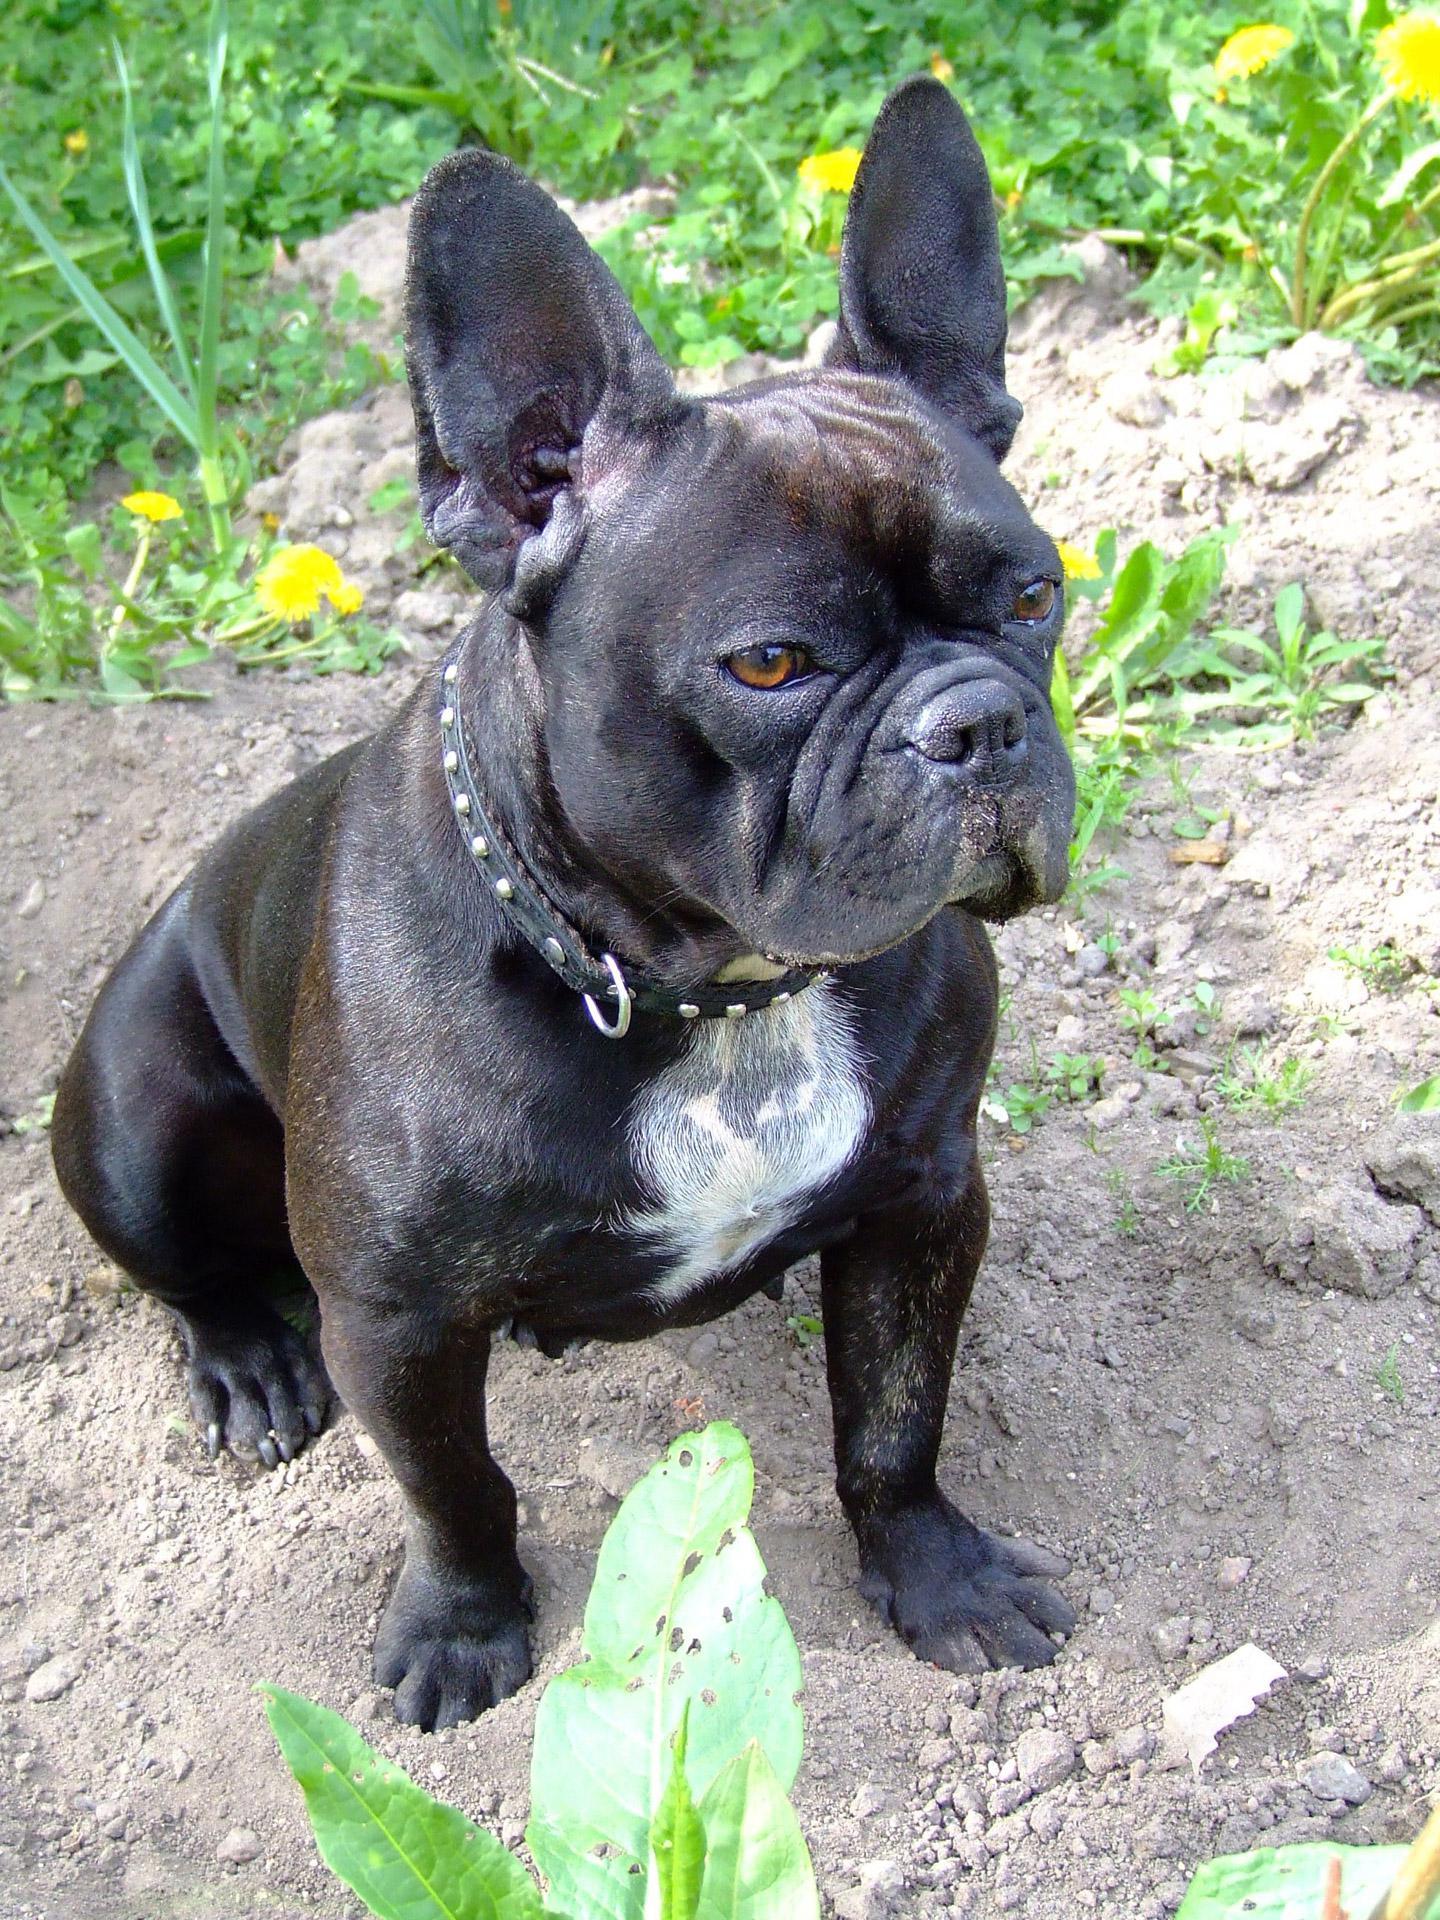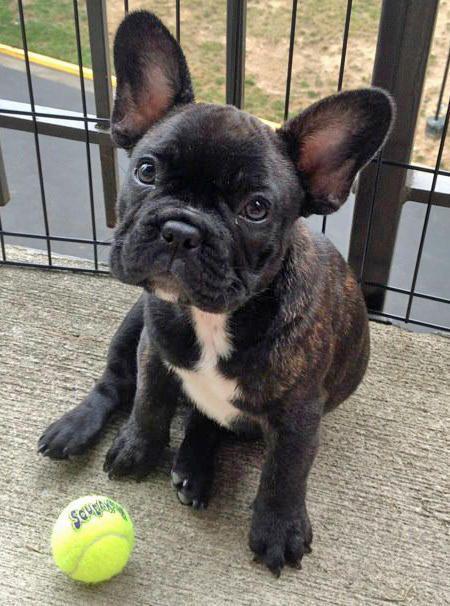The first image is the image on the left, the second image is the image on the right. For the images shown, is this caption "All the dogs are sitting." true? Answer yes or no. Yes. The first image is the image on the left, the second image is the image on the right. Evaluate the accuracy of this statement regarding the images: "Each image contains a dark french bulldog in a sitting pose, and the dog in the left image has its body turned rightward while the dog on the right looks directly at the camera.". Is it true? Answer yes or no. Yes. 